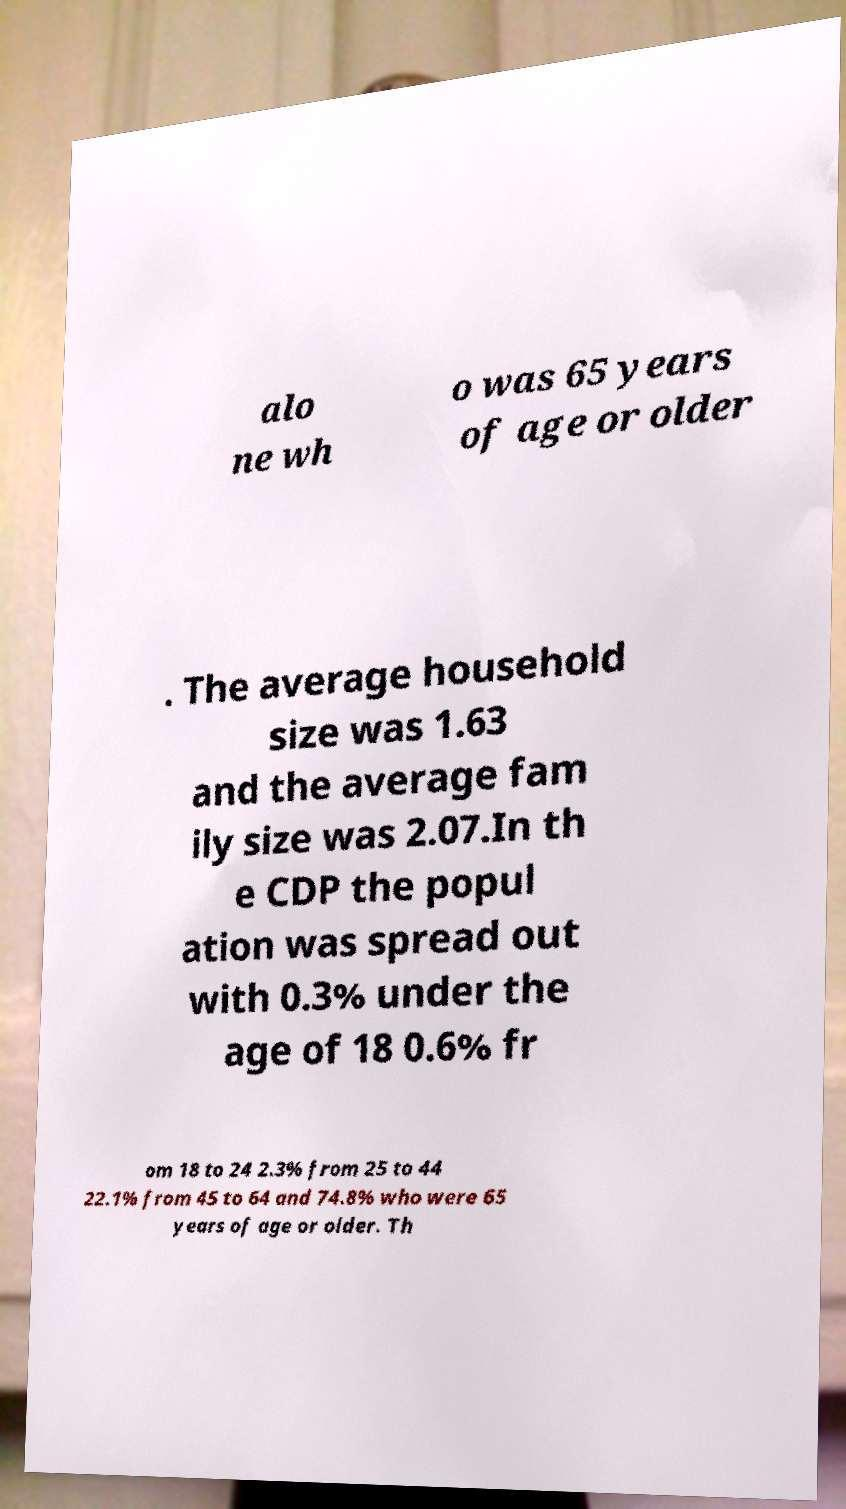Please identify and transcribe the text found in this image. alo ne wh o was 65 years of age or older . The average household size was 1.63 and the average fam ily size was 2.07.In th e CDP the popul ation was spread out with 0.3% under the age of 18 0.6% fr om 18 to 24 2.3% from 25 to 44 22.1% from 45 to 64 and 74.8% who were 65 years of age or older. Th 